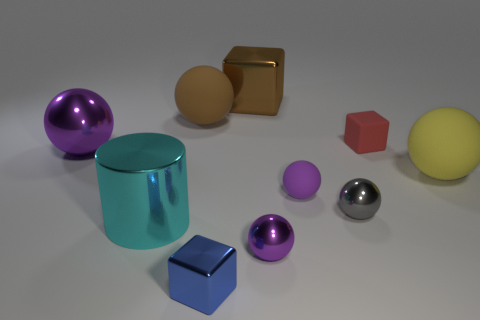What is the shape of the big rubber thing that is behind the purple object that is left of the cylinder?
Give a very brief answer. Sphere. Do the tiny rubber ball and the large metallic sphere have the same color?
Give a very brief answer. Yes. How many red things are big metallic balls or rubber cubes?
Make the answer very short. 1. Are there any brown shiny blocks behind the red thing?
Provide a short and direct response. Yes. What size is the blue thing?
Give a very brief answer. Small. What size is the yellow rubber object that is the same shape as the tiny gray object?
Ensure brevity in your answer.  Large. There is a purple metallic sphere that is behind the gray sphere; what number of rubber spheres are in front of it?
Offer a very short reply. 2. Is the ball on the right side of the matte block made of the same material as the tiny cube in front of the large metal ball?
Offer a terse response. No. How many other tiny objects have the same shape as the red object?
Provide a short and direct response. 1. What number of big matte spheres are the same color as the large metal block?
Keep it short and to the point. 1. 